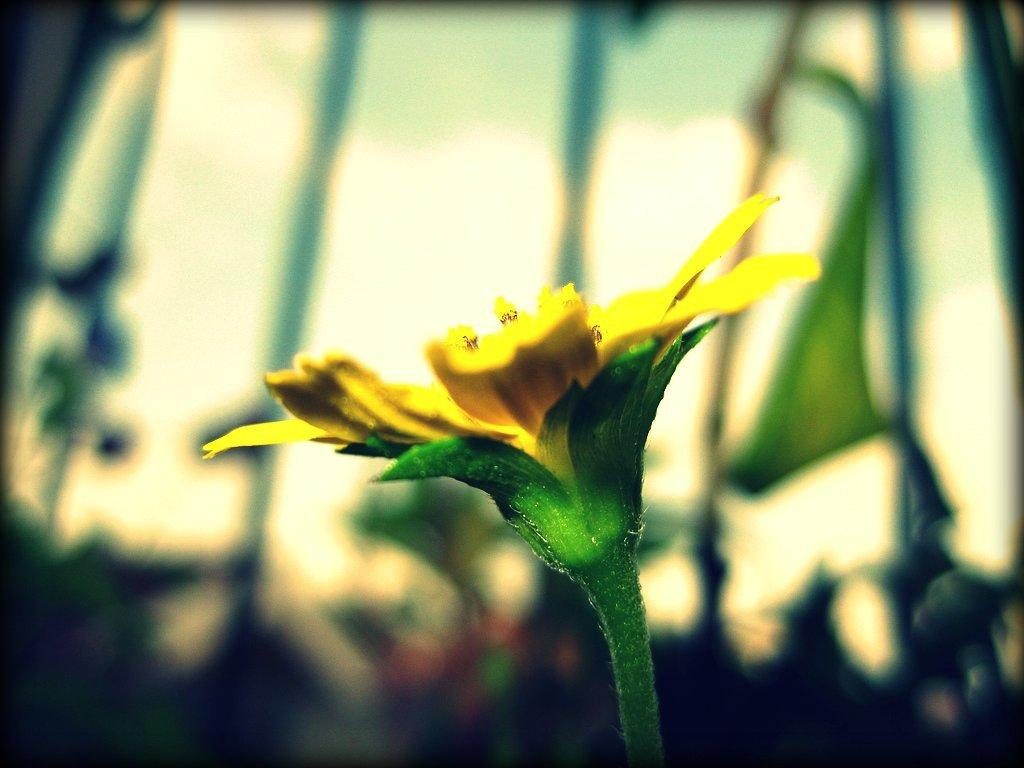What is the main subject of the image? There is a flower in the image. What color is the flower? The flower is yellow. Can you describe any other objects or features in the image? There are other objects in the background of the image. What type of chain is wrapped around the flower in the image? There is no chain present in the image; it only features a yellow flower and other objects in the background. 